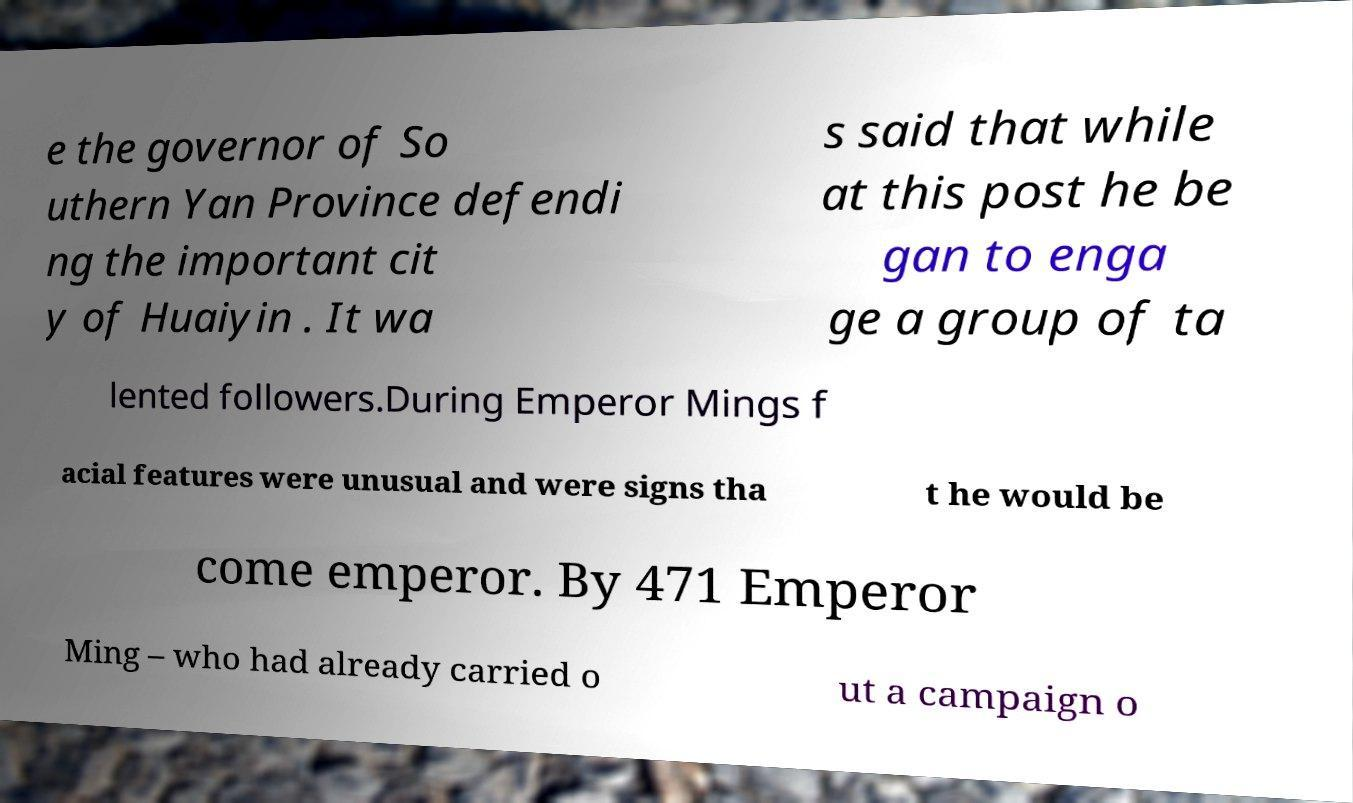Can you read and provide the text displayed in the image?This photo seems to have some interesting text. Can you extract and type it out for me? e the governor of So uthern Yan Province defendi ng the important cit y of Huaiyin . It wa s said that while at this post he be gan to enga ge a group of ta lented followers.During Emperor Mings f acial features were unusual and were signs tha t he would be come emperor. By 471 Emperor Ming – who had already carried o ut a campaign o 